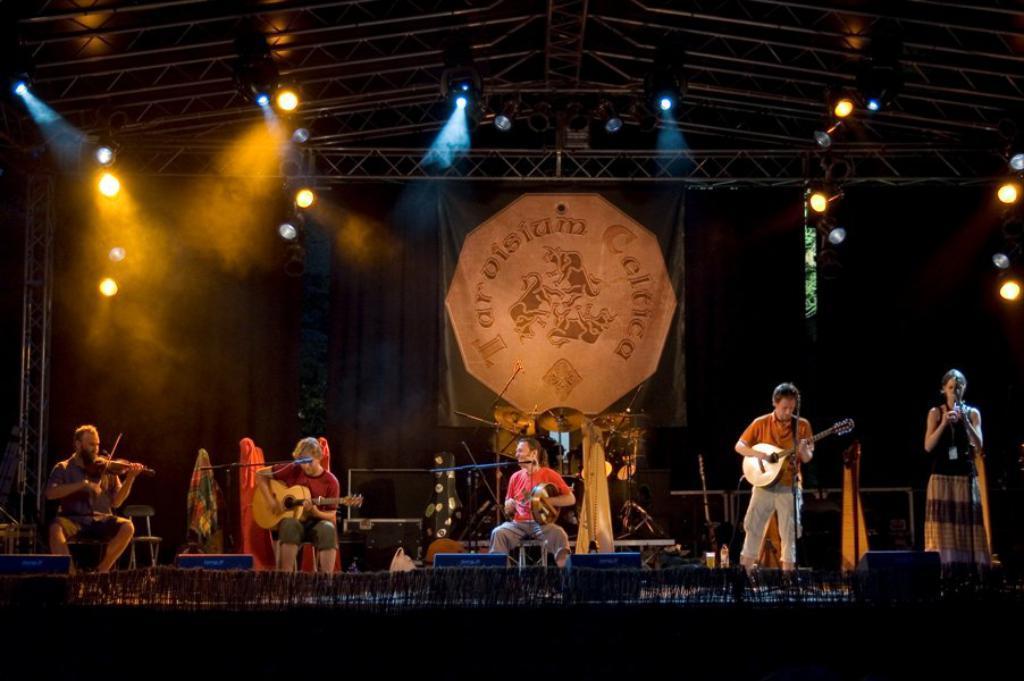Could you give a brief overview of what you see in this image? In this picture I can observe a music band on the stage. There are five members on the stage. Four of them are playing musical instruments in their hands. One of them is a woman. In the background I can observe curtains and lights. 